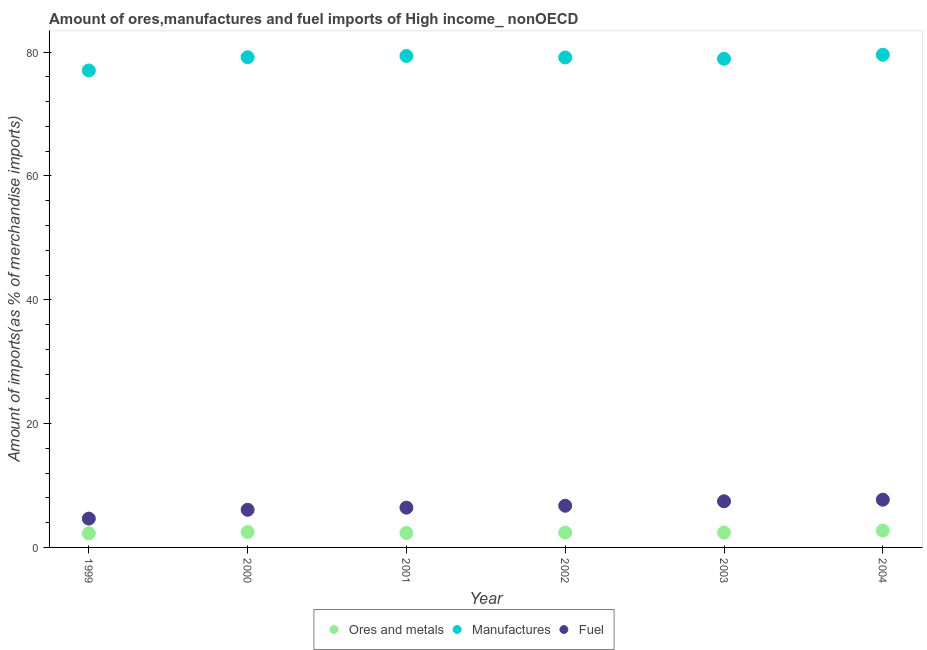What is the percentage of manufactures imports in 2001?
Make the answer very short. 79.38. Across all years, what is the maximum percentage of fuel imports?
Your answer should be very brief. 7.71. Across all years, what is the minimum percentage of ores and metals imports?
Give a very brief answer. 2.27. In which year was the percentage of manufactures imports minimum?
Ensure brevity in your answer.  1999. What is the total percentage of manufactures imports in the graph?
Keep it short and to the point. 473.25. What is the difference between the percentage of manufactures imports in 2001 and that in 2003?
Make the answer very short. 0.45. What is the difference between the percentage of fuel imports in 2001 and the percentage of ores and metals imports in 2000?
Your answer should be compact. 3.94. What is the average percentage of fuel imports per year?
Your answer should be compact. 6.51. In the year 2004, what is the difference between the percentage of ores and metals imports and percentage of manufactures imports?
Your answer should be compact. -76.86. In how many years, is the percentage of ores and metals imports greater than 60 %?
Your answer should be compact. 0. What is the ratio of the percentage of manufactures imports in 2001 to that in 2002?
Your response must be concise. 1. What is the difference between the highest and the second highest percentage of manufactures imports?
Give a very brief answer. 0.2. What is the difference between the highest and the lowest percentage of manufactures imports?
Offer a very short reply. 2.54. In how many years, is the percentage of fuel imports greater than the average percentage of fuel imports taken over all years?
Your answer should be very brief. 3. Does the percentage of manufactures imports monotonically increase over the years?
Offer a terse response. No. How many dotlines are there?
Your answer should be compact. 3. How many years are there in the graph?
Offer a very short reply. 6. Does the graph contain grids?
Give a very brief answer. No. Where does the legend appear in the graph?
Ensure brevity in your answer.  Bottom center. How many legend labels are there?
Offer a terse response. 3. What is the title of the graph?
Offer a terse response. Amount of ores,manufactures and fuel imports of High income_ nonOECD. What is the label or title of the Y-axis?
Your answer should be compact. Amount of imports(as % of merchandise imports). What is the Amount of imports(as % of merchandise imports) in Ores and metals in 1999?
Provide a succinct answer. 2.27. What is the Amount of imports(as % of merchandise imports) of Manufactures in 1999?
Your answer should be very brief. 77.04. What is the Amount of imports(as % of merchandise imports) of Fuel in 1999?
Your answer should be compact. 4.66. What is the Amount of imports(as % of merchandise imports) in Ores and metals in 2000?
Keep it short and to the point. 2.49. What is the Amount of imports(as % of merchandise imports) of Manufactures in 2000?
Your answer should be compact. 79.18. What is the Amount of imports(as % of merchandise imports) of Fuel in 2000?
Keep it short and to the point. 6.08. What is the Amount of imports(as % of merchandise imports) in Ores and metals in 2001?
Ensure brevity in your answer.  2.34. What is the Amount of imports(as % of merchandise imports) of Manufactures in 2001?
Offer a terse response. 79.38. What is the Amount of imports(as % of merchandise imports) in Fuel in 2001?
Your response must be concise. 6.42. What is the Amount of imports(as % of merchandise imports) in Ores and metals in 2002?
Offer a very short reply. 2.4. What is the Amount of imports(as % of merchandise imports) in Manufactures in 2002?
Give a very brief answer. 79.14. What is the Amount of imports(as % of merchandise imports) of Fuel in 2002?
Give a very brief answer. 6.73. What is the Amount of imports(as % of merchandise imports) in Ores and metals in 2003?
Make the answer very short. 2.4. What is the Amount of imports(as % of merchandise imports) of Manufactures in 2003?
Your answer should be compact. 78.93. What is the Amount of imports(as % of merchandise imports) in Fuel in 2003?
Offer a terse response. 7.45. What is the Amount of imports(as % of merchandise imports) of Ores and metals in 2004?
Offer a terse response. 2.72. What is the Amount of imports(as % of merchandise imports) of Manufactures in 2004?
Offer a very short reply. 79.58. What is the Amount of imports(as % of merchandise imports) of Fuel in 2004?
Offer a very short reply. 7.71. Across all years, what is the maximum Amount of imports(as % of merchandise imports) in Ores and metals?
Your answer should be compact. 2.72. Across all years, what is the maximum Amount of imports(as % of merchandise imports) in Manufactures?
Give a very brief answer. 79.58. Across all years, what is the maximum Amount of imports(as % of merchandise imports) in Fuel?
Offer a very short reply. 7.71. Across all years, what is the minimum Amount of imports(as % of merchandise imports) in Ores and metals?
Offer a very short reply. 2.27. Across all years, what is the minimum Amount of imports(as % of merchandise imports) in Manufactures?
Your answer should be compact. 77.04. Across all years, what is the minimum Amount of imports(as % of merchandise imports) of Fuel?
Offer a terse response. 4.66. What is the total Amount of imports(as % of merchandise imports) in Ores and metals in the graph?
Offer a very short reply. 14.62. What is the total Amount of imports(as % of merchandise imports) in Manufactures in the graph?
Your answer should be very brief. 473.25. What is the total Amount of imports(as % of merchandise imports) of Fuel in the graph?
Make the answer very short. 39.06. What is the difference between the Amount of imports(as % of merchandise imports) in Ores and metals in 1999 and that in 2000?
Give a very brief answer. -0.22. What is the difference between the Amount of imports(as % of merchandise imports) of Manufactures in 1999 and that in 2000?
Your response must be concise. -2.14. What is the difference between the Amount of imports(as % of merchandise imports) in Fuel in 1999 and that in 2000?
Give a very brief answer. -1.42. What is the difference between the Amount of imports(as % of merchandise imports) of Ores and metals in 1999 and that in 2001?
Make the answer very short. -0.07. What is the difference between the Amount of imports(as % of merchandise imports) of Manufactures in 1999 and that in 2001?
Your answer should be very brief. -2.34. What is the difference between the Amount of imports(as % of merchandise imports) of Fuel in 1999 and that in 2001?
Offer a very short reply. -1.77. What is the difference between the Amount of imports(as % of merchandise imports) of Ores and metals in 1999 and that in 2002?
Your answer should be very brief. -0.12. What is the difference between the Amount of imports(as % of merchandise imports) in Manufactures in 1999 and that in 2002?
Make the answer very short. -2.1. What is the difference between the Amount of imports(as % of merchandise imports) in Fuel in 1999 and that in 2002?
Provide a short and direct response. -2.08. What is the difference between the Amount of imports(as % of merchandise imports) in Ores and metals in 1999 and that in 2003?
Make the answer very short. -0.13. What is the difference between the Amount of imports(as % of merchandise imports) in Manufactures in 1999 and that in 2003?
Ensure brevity in your answer.  -1.89. What is the difference between the Amount of imports(as % of merchandise imports) of Fuel in 1999 and that in 2003?
Provide a short and direct response. -2.79. What is the difference between the Amount of imports(as % of merchandise imports) of Ores and metals in 1999 and that in 2004?
Ensure brevity in your answer.  -0.45. What is the difference between the Amount of imports(as % of merchandise imports) in Manufactures in 1999 and that in 2004?
Provide a short and direct response. -2.54. What is the difference between the Amount of imports(as % of merchandise imports) in Fuel in 1999 and that in 2004?
Make the answer very short. -3.05. What is the difference between the Amount of imports(as % of merchandise imports) in Ores and metals in 2000 and that in 2001?
Make the answer very short. 0.15. What is the difference between the Amount of imports(as % of merchandise imports) in Manufactures in 2000 and that in 2001?
Provide a short and direct response. -0.2. What is the difference between the Amount of imports(as % of merchandise imports) in Fuel in 2000 and that in 2001?
Make the answer very short. -0.34. What is the difference between the Amount of imports(as % of merchandise imports) in Ores and metals in 2000 and that in 2002?
Your response must be concise. 0.09. What is the difference between the Amount of imports(as % of merchandise imports) of Manufactures in 2000 and that in 2002?
Ensure brevity in your answer.  0.04. What is the difference between the Amount of imports(as % of merchandise imports) in Fuel in 2000 and that in 2002?
Offer a very short reply. -0.65. What is the difference between the Amount of imports(as % of merchandise imports) of Ores and metals in 2000 and that in 2003?
Provide a succinct answer. 0.09. What is the difference between the Amount of imports(as % of merchandise imports) of Manufactures in 2000 and that in 2003?
Offer a terse response. 0.25. What is the difference between the Amount of imports(as % of merchandise imports) of Fuel in 2000 and that in 2003?
Offer a terse response. -1.37. What is the difference between the Amount of imports(as % of merchandise imports) in Ores and metals in 2000 and that in 2004?
Keep it short and to the point. -0.23. What is the difference between the Amount of imports(as % of merchandise imports) of Manufactures in 2000 and that in 2004?
Your answer should be compact. -0.4. What is the difference between the Amount of imports(as % of merchandise imports) of Fuel in 2000 and that in 2004?
Keep it short and to the point. -1.63. What is the difference between the Amount of imports(as % of merchandise imports) of Ores and metals in 2001 and that in 2002?
Offer a terse response. -0.05. What is the difference between the Amount of imports(as % of merchandise imports) of Manufactures in 2001 and that in 2002?
Offer a terse response. 0.24. What is the difference between the Amount of imports(as % of merchandise imports) in Fuel in 2001 and that in 2002?
Offer a very short reply. -0.31. What is the difference between the Amount of imports(as % of merchandise imports) of Ores and metals in 2001 and that in 2003?
Offer a very short reply. -0.06. What is the difference between the Amount of imports(as % of merchandise imports) in Manufactures in 2001 and that in 2003?
Make the answer very short. 0.45. What is the difference between the Amount of imports(as % of merchandise imports) of Fuel in 2001 and that in 2003?
Provide a succinct answer. -1.03. What is the difference between the Amount of imports(as % of merchandise imports) of Ores and metals in 2001 and that in 2004?
Provide a succinct answer. -0.38. What is the difference between the Amount of imports(as % of merchandise imports) of Manufactures in 2001 and that in 2004?
Offer a very short reply. -0.2. What is the difference between the Amount of imports(as % of merchandise imports) of Fuel in 2001 and that in 2004?
Provide a short and direct response. -1.29. What is the difference between the Amount of imports(as % of merchandise imports) of Ores and metals in 2002 and that in 2003?
Your response must be concise. -0. What is the difference between the Amount of imports(as % of merchandise imports) of Manufactures in 2002 and that in 2003?
Your answer should be very brief. 0.21. What is the difference between the Amount of imports(as % of merchandise imports) of Fuel in 2002 and that in 2003?
Keep it short and to the point. -0.72. What is the difference between the Amount of imports(as % of merchandise imports) of Ores and metals in 2002 and that in 2004?
Your response must be concise. -0.33. What is the difference between the Amount of imports(as % of merchandise imports) in Manufactures in 2002 and that in 2004?
Provide a succinct answer. -0.44. What is the difference between the Amount of imports(as % of merchandise imports) of Fuel in 2002 and that in 2004?
Ensure brevity in your answer.  -0.98. What is the difference between the Amount of imports(as % of merchandise imports) of Ores and metals in 2003 and that in 2004?
Make the answer very short. -0.32. What is the difference between the Amount of imports(as % of merchandise imports) in Manufactures in 2003 and that in 2004?
Make the answer very short. -0.65. What is the difference between the Amount of imports(as % of merchandise imports) of Fuel in 2003 and that in 2004?
Offer a terse response. -0.26. What is the difference between the Amount of imports(as % of merchandise imports) in Ores and metals in 1999 and the Amount of imports(as % of merchandise imports) in Manufactures in 2000?
Your response must be concise. -76.91. What is the difference between the Amount of imports(as % of merchandise imports) in Ores and metals in 1999 and the Amount of imports(as % of merchandise imports) in Fuel in 2000?
Keep it short and to the point. -3.81. What is the difference between the Amount of imports(as % of merchandise imports) in Manufactures in 1999 and the Amount of imports(as % of merchandise imports) in Fuel in 2000?
Give a very brief answer. 70.96. What is the difference between the Amount of imports(as % of merchandise imports) in Ores and metals in 1999 and the Amount of imports(as % of merchandise imports) in Manufactures in 2001?
Your answer should be compact. -77.11. What is the difference between the Amount of imports(as % of merchandise imports) in Ores and metals in 1999 and the Amount of imports(as % of merchandise imports) in Fuel in 2001?
Offer a terse response. -4.15. What is the difference between the Amount of imports(as % of merchandise imports) of Manufactures in 1999 and the Amount of imports(as % of merchandise imports) of Fuel in 2001?
Make the answer very short. 70.62. What is the difference between the Amount of imports(as % of merchandise imports) in Ores and metals in 1999 and the Amount of imports(as % of merchandise imports) in Manufactures in 2002?
Make the answer very short. -76.87. What is the difference between the Amount of imports(as % of merchandise imports) of Ores and metals in 1999 and the Amount of imports(as % of merchandise imports) of Fuel in 2002?
Offer a terse response. -4.46. What is the difference between the Amount of imports(as % of merchandise imports) in Manufactures in 1999 and the Amount of imports(as % of merchandise imports) in Fuel in 2002?
Your answer should be very brief. 70.31. What is the difference between the Amount of imports(as % of merchandise imports) of Ores and metals in 1999 and the Amount of imports(as % of merchandise imports) of Manufactures in 2003?
Give a very brief answer. -76.66. What is the difference between the Amount of imports(as % of merchandise imports) in Ores and metals in 1999 and the Amount of imports(as % of merchandise imports) in Fuel in 2003?
Your response must be concise. -5.18. What is the difference between the Amount of imports(as % of merchandise imports) in Manufactures in 1999 and the Amount of imports(as % of merchandise imports) in Fuel in 2003?
Offer a terse response. 69.59. What is the difference between the Amount of imports(as % of merchandise imports) of Ores and metals in 1999 and the Amount of imports(as % of merchandise imports) of Manufactures in 2004?
Keep it short and to the point. -77.31. What is the difference between the Amount of imports(as % of merchandise imports) of Ores and metals in 1999 and the Amount of imports(as % of merchandise imports) of Fuel in 2004?
Offer a terse response. -5.44. What is the difference between the Amount of imports(as % of merchandise imports) of Manufactures in 1999 and the Amount of imports(as % of merchandise imports) of Fuel in 2004?
Provide a short and direct response. 69.33. What is the difference between the Amount of imports(as % of merchandise imports) of Ores and metals in 2000 and the Amount of imports(as % of merchandise imports) of Manufactures in 2001?
Offer a very short reply. -76.89. What is the difference between the Amount of imports(as % of merchandise imports) in Ores and metals in 2000 and the Amount of imports(as % of merchandise imports) in Fuel in 2001?
Ensure brevity in your answer.  -3.94. What is the difference between the Amount of imports(as % of merchandise imports) of Manufactures in 2000 and the Amount of imports(as % of merchandise imports) of Fuel in 2001?
Provide a succinct answer. 72.76. What is the difference between the Amount of imports(as % of merchandise imports) in Ores and metals in 2000 and the Amount of imports(as % of merchandise imports) in Manufactures in 2002?
Ensure brevity in your answer.  -76.65. What is the difference between the Amount of imports(as % of merchandise imports) in Ores and metals in 2000 and the Amount of imports(as % of merchandise imports) in Fuel in 2002?
Your response must be concise. -4.25. What is the difference between the Amount of imports(as % of merchandise imports) of Manufactures in 2000 and the Amount of imports(as % of merchandise imports) of Fuel in 2002?
Your answer should be very brief. 72.45. What is the difference between the Amount of imports(as % of merchandise imports) of Ores and metals in 2000 and the Amount of imports(as % of merchandise imports) of Manufactures in 2003?
Provide a short and direct response. -76.44. What is the difference between the Amount of imports(as % of merchandise imports) of Ores and metals in 2000 and the Amount of imports(as % of merchandise imports) of Fuel in 2003?
Make the answer very short. -4.96. What is the difference between the Amount of imports(as % of merchandise imports) in Manufactures in 2000 and the Amount of imports(as % of merchandise imports) in Fuel in 2003?
Keep it short and to the point. 71.73. What is the difference between the Amount of imports(as % of merchandise imports) in Ores and metals in 2000 and the Amount of imports(as % of merchandise imports) in Manufactures in 2004?
Your answer should be very brief. -77.09. What is the difference between the Amount of imports(as % of merchandise imports) in Ores and metals in 2000 and the Amount of imports(as % of merchandise imports) in Fuel in 2004?
Keep it short and to the point. -5.22. What is the difference between the Amount of imports(as % of merchandise imports) in Manufactures in 2000 and the Amount of imports(as % of merchandise imports) in Fuel in 2004?
Your response must be concise. 71.47. What is the difference between the Amount of imports(as % of merchandise imports) of Ores and metals in 2001 and the Amount of imports(as % of merchandise imports) of Manufactures in 2002?
Your answer should be very brief. -76.8. What is the difference between the Amount of imports(as % of merchandise imports) of Ores and metals in 2001 and the Amount of imports(as % of merchandise imports) of Fuel in 2002?
Your answer should be compact. -4.39. What is the difference between the Amount of imports(as % of merchandise imports) of Manufactures in 2001 and the Amount of imports(as % of merchandise imports) of Fuel in 2002?
Give a very brief answer. 72.65. What is the difference between the Amount of imports(as % of merchandise imports) of Ores and metals in 2001 and the Amount of imports(as % of merchandise imports) of Manufactures in 2003?
Your answer should be very brief. -76.59. What is the difference between the Amount of imports(as % of merchandise imports) in Ores and metals in 2001 and the Amount of imports(as % of merchandise imports) in Fuel in 2003?
Make the answer very short. -5.11. What is the difference between the Amount of imports(as % of merchandise imports) of Manufactures in 2001 and the Amount of imports(as % of merchandise imports) of Fuel in 2003?
Provide a succinct answer. 71.93. What is the difference between the Amount of imports(as % of merchandise imports) in Ores and metals in 2001 and the Amount of imports(as % of merchandise imports) in Manufactures in 2004?
Give a very brief answer. -77.24. What is the difference between the Amount of imports(as % of merchandise imports) of Ores and metals in 2001 and the Amount of imports(as % of merchandise imports) of Fuel in 2004?
Your response must be concise. -5.37. What is the difference between the Amount of imports(as % of merchandise imports) of Manufactures in 2001 and the Amount of imports(as % of merchandise imports) of Fuel in 2004?
Ensure brevity in your answer.  71.67. What is the difference between the Amount of imports(as % of merchandise imports) of Ores and metals in 2002 and the Amount of imports(as % of merchandise imports) of Manufactures in 2003?
Ensure brevity in your answer.  -76.54. What is the difference between the Amount of imports(as % of merchandise imports) of Ores and metals in 2002 and the Amount of imports(as % of merchandise imports) of Fuel in 2003?
Your response must be concise. -5.06. What is the difference between the Amount of imports(as % of merchandise imports) in Manufactures in 2002 and the Amount of imports(as % of merchandise imports) in Fuel in 2003?
Your response must be concise. 71.69. What is the difference between the Amount of imports(as % of merchandise imports) in Ores and metals in 2002 and the Amount of imports(as % of merchandise imports) in Manufactures in 2004?
Keep it short and to the point. -77.18. What is the difference between the Amount of imports(as % of merchandise imports) in Ores and metals in 2002 and the Amount of imports(as % of merchandise imports) in Fuel in 2004?
Your response must be concise. -5.32. What is the difference between the Amount of imports(as % of merchandise imports) in Manufactures in 2002 and the Amount of imports(as % of merchandise imports) in Fuel in 2004?
Make the answer very short. 71.43. What is the difference between the Amount of imports(as % of merchandise imports) in Ores and metals in 2003 and the Amount of imports(as % of merchandise imports) in Manufactures in 2004?
Give a very brief answer. -77.18. What is the difference between the Amount of imports(as % of merchandise imports) in Ores and metals in 2003 and the Amount of imports(as % of merchandise imports) in Fuel in 2004?
Your response must be concise. -5.31. What is the difference between the Amount of imports(as % of merchandise imports) in Manufactures in 2003 and the Amount of imports(as % of merchandise imports) in Fuel in 2004?
Your answer should be compact. 71.22. What is the average Amount of imports(as % of merchandise imports) in Ores and metals per year?
Your answer should be compact. 2.44. What is the average Amount of imports(as % of merchandise imports) of Manufactures per year?
Give a very brief answer. 78.88. What is the average Amount of imports(as % of merchandise imports) of Fuel per year?
Provide a succinct answer. 6.51. In the year 1999, what is the difference between the Amount of imports(as % of merchandise imports) in Ores and metals and Amount of imports(as % of merchandise imports) in Manufactures?
Your response must be concise. -74.77. In the year 1999, what is the difference between the Amount of imports(as % of merchandise imports) in Ores and metals and Amount of imports(as % of merchandise imports) in Fuel?
Your response must be concise. -2.39. In the year 1999, what is the difference between the Amount of imports(as % of merchandise imports) of Manufactures and Amount of imports(as % of merchandise imports) of Fuel?
Provide a succinct answer. 72.38. In the year 2000, what is the difference between the Amount of imports(as % of merchandise imports) of Ores and metals and Amount of imports(as % of merchandise imports) of Manufactures?
Provide a short and direct response. -76.69. In the year 2000, what is the difference between the Amount of imports(as % of merchandise imports) of Ores and metals and Amount of imports(as % of merchandise imports) of Fuel?
Give a very brief answer. -3.59. In the year 2000, what is the difference between the Amount of imports(as % of merchandise imports) in Manufactures and Amount of imports(as % of merchandise imports) in Fuel?
Your answer should be compact. 73.1. In the year 2001, what is the difference between the Amount of imports(as % of merchandise imports) in Ores and metals and Amount of imports(as % of merchandise imports) in Manufactures?
Keep it short and to the point. -77.04. In the year 2001, what is the difference between the Amount of imports(as % of merchandise imports) of Ores and metals and Amount of imports(as % of merchandise imports) of Fuel?
Your answer should be compact. -4.08. In the year 2001, what is the difference between the Amount of imports(as % of merchandise imports) of Manufactures and Amount of imports(as % of merchandise imports) of Fuel?
Your answer should be compact. 72.96. In the year 2002, what is the difference between the Amount of imports(as % of merchandise imports) in Ores and metals and Amount of imports(as % of merchandise imports) in Manufactures?
Make the answer very short. -76.74. In the year 2002, what is the difference between the Amount of imports(as % of merchandise imports) in Ores and metals and Amount of imports(as % of merchandise imports) in Fuel?
Provide a short and direct response. -4.34. In the year 2002, what is the difference between the Amount of imports(as % of merchandise imports) in Manufactures and Amount of imports(as % of merchandise imports) in Fuel?
Your answer should be compact. 72.4. In the year 2003, what is the difference between the Amount of imports(as % of merchandise imports) of Ores and metals and Amount of imports(as % of merchandise imports) of Manufactures?
Provide a succinct answer. -76.53. In the year 2003, what is the difference between the Amount of imports(as % of merchandise imports) in Ores and metals and Amount of imports(as % of merchandise imports) in Fuel?
Keep it short and to the point. -5.05. In the year 2003, what is the difference between the Amount of imports(as % of merchandise imports) in Manufactures and Amount of imports(as % of merchandise imports) in Fuel?
Ensure brevity in your answer.  71.48. In the year 2004, what is the difference between the Amount of imports(as % of merchandise imports) in Ores and metals and Amount of imports(as % of merchandise imports) in Manufactures?
Provide a short and direct response. -76.86. In the year 2004, what is the difference between the Amount of imports(as % of merchandise imports) in Ores and metals and Amount of imports(as % of merchandise imports) in Fuel?
Provide a succinct answer. -4.99. In the year 2004, what is the difference between the Amount of imports(as % of merchandise imports) of Manufactures and Amount of imports(as % of merchandise imports) of Fuel?
Your response must be concise. 71.87. What is the ratio of the Amount of imports(as % of merchandise imports) in Ores and metals in 1999 to that in 2000?
Offer a terse response. 0.91. What is the ratio of the Amount of imports(as % of merchandise imports) of Manufactures in 1999 to that in 2000?
Offer a terse response. 0.97. What is the ratio of the Amount of imports(as % of merchandise imports) of Fuel in 1999 to that in 2000?
Your answer should be very brief. 0.77. What is the ratio of the Amount of imports(as % of merchandise imports) of Ores and metals in 1999 to that in 2001?
Give a very brief answer. 0.97. What is the ratio of the Amount of imports(as % of merchandise imports) of Manufactures in 1999 to that in 2001?
Ensure brevity in your answer.  0.97. What is the ratio of the Amount of imports(as % of merchandise imports) of Fuel in 1999 to that in 2001?
Your answer should be very brief. 0.72. What is the ratio of the Amount of imports(as % of merchandise imports) in Ores and metals in 1999 to that in 2002?
Your answer should be compact. 0.95. What is the ratio of the Amount of imports(as % of merchandise imports) of Manufactures in 1999 to that in 2002?
Your answer should be compact. 0.97. What is the ratio of the Amount of imports(as % of merchandise imports) in Fuel in 1999 to that in 2002?
Provide a short and direct response. 0.69. What is the ratio of the Amount of imports(as % of merchandise imports) in Ores and metals in 1999 to that in 2003?
Your response must be concise. 0.95. What is the ratio of the Amount of imports(as % of merchandise imports) in Manufactures in 1999 to that in 2003?
Give a very brief answer. 0.98. What is the ratio of the Amount of imports(as % of merchandise imports) of Fuel in 1999 to that in 2003?
Ensure brevity in your answer.  0.62. What is the ratio of the Amount of imports(as % of merchandise imports) in Ores and metals in 1999 to that in 2004?
Make the answer very short. 0.83. What is the ratio of the Amount of imports(as % of merchandise imports) of Manufactures in 1999 to that in 2004?
Ensure brevity in your answer.  0.97. What is the ratio of the Amount of imports(as % of merchandise imports) in Fuel in 1999 to that in 2004?
Ensure brevity in your answer.  0.6. What is the ratio of the Amount of imports(as % of merchandise imports) in Ores and metals in 2000 to that in 2001?
Make the answer very short. 1.06. What is the ratio of the Amount of imports(as % of merchandise imports) of Manufactures in 2000 to that in 2001?
Offer a terse response. 1. What is the ratio of the Amount of imports(as % of merchandise imports) in Fuel in 2000 to that in 2001?
Ensure brevity in your answer.  0.95. What is the ratio of the Amount of imports(as % of merchandise imports) of Ores and metals in 2000 to that in 2002?
Your answer should be very brief. 1.04. What is the ratio of the Amount of imports(as % of merchandise imports) of Fuel in 2000 to that in 2002?
Ensure brevity in your answer.  0.9. What is the ratio of the Amount of imports(as % of merchandise imports) in Manufactures in 2000 to that in 2003?
Keep it short and to the point. 1. What is the ratio of the Amount of imports(as % of merchandise imports) in Fuel in 2000 to that in 2003?
Provide a short and direct response. 0.82. What is the ratio of the Amount of imports(as % of merchandise imports) of Ores and metals in 2000 to that in 2004?
Provide a short and direct response. 0.91. What is the ratio of the Amount of imports(as % of merchandise imports) of Manufactures in 2000 to that in 2004?
Your answer should be very brief. 0.99. What is the ratio of the Amount of imports(as % of merchandise imports) in Fuel in 2000 to that in 2004?
Keep it short and to the point. 0.79. What is the ratio of the Amount of imports(as % of merchandise imports) in Ores and metals in 2001 to that in 2002?
Your response must be concise. 0.98. What is the ratio of the Amount of imports(as % of merchandise imports) in Manufactures in 2001 to that in 2002?
Your answer should be very brief. 1. What is the ratio of the Amount of imports(as % of merchandise imports) in Fuel in 2001 to that in 2002?
Keep it short and to the point. 0.95. What is the ratio of the Amount of imports(as % of merchandise imports) in Ores and metals in 2001 to that in 2003?
Give a very brief answer. 0.98. What is the ratio of the Amount of imports(as % of merchandise imports) in Manufactures in 2001 to that in 2003?
Offer a terse response. 1.01. What is the ratio of the Amount of imports(as % of merchandise imports) in Fuel in 2001 to that in 2003?
Offer a very short reply. 0.86. What is the ratio of the Amount of imports(as % of merchandise imports) of Ores and metals in 2001 to that in 2004?
Your answer should be compact. 0.86. What is the ratio of the Amount of imports(as % of merchandise imports) in Manufactures in 2001 to that in 2004?
Offer a very short reply. 1. What is the ratio of the Amount of imports(as % of merchandise imports) of Fuel in 2001 to that in 2004?
Make the answer very short. 0.83. What is the ratio of the Amount of imports(as % of merchandise imports) in Manufactures in 2002 to that in 2003?
Give a very brief answer. 1. What is the ratio of the Amount of imports(as % of merchandise imports) in Fuel in 2002 to that in 2003?
Make the answer very short. 0.9. What is the ratio of the Amount of imports(as % of merchandise imports) in Ores and metals in 2002 to that in 2004?
Give a very brief answer. 0.88. What is the ratio of the Amount of imports(as % of merchandise imports) of Fuel in 2002 to that in 2004?
Provide a short and direct response. 0.87. What is the ratio of the Amount of imports(as % of merchandise imports) in Ores and metals in 2003 to that in 2004?
Keep it short and to the point. 0.88. What is the ratio of the Amount of imports(as % of merchandise imports) in Fuel in 2003 to that in 2004?
Provide a short and direct response. 0.97. What is the difference between the highest and the second highest Amount of imports(as % of merchandise imports) in Ores and metals?
Your answer should be very brief. 0.23. What is the difference between the highest and the second highest Amount of imports(as % of merchandise imports) of Manufactures?
Provide a succinct answer. 0.2. What is the difference between the highest and the second highest Amount of imports(as % of merchandise imports) in Fuel?
Make the answer very short. 0.26. What is the difference between the highest and the lowest Amount of imports(as % of merchandise imports) of Ores and metals?
Your response must be concise. 0.45. What is the difference between the highest and the lowest Amount of imports(as % of merchandise imports) in Manufactures?
Provide a short and direct response. 2.54. What is the difference between the highest and the lowest Amount of imports(as % of merchandise imports) in Fuel?
Provide a short and direct response. 3.05. 